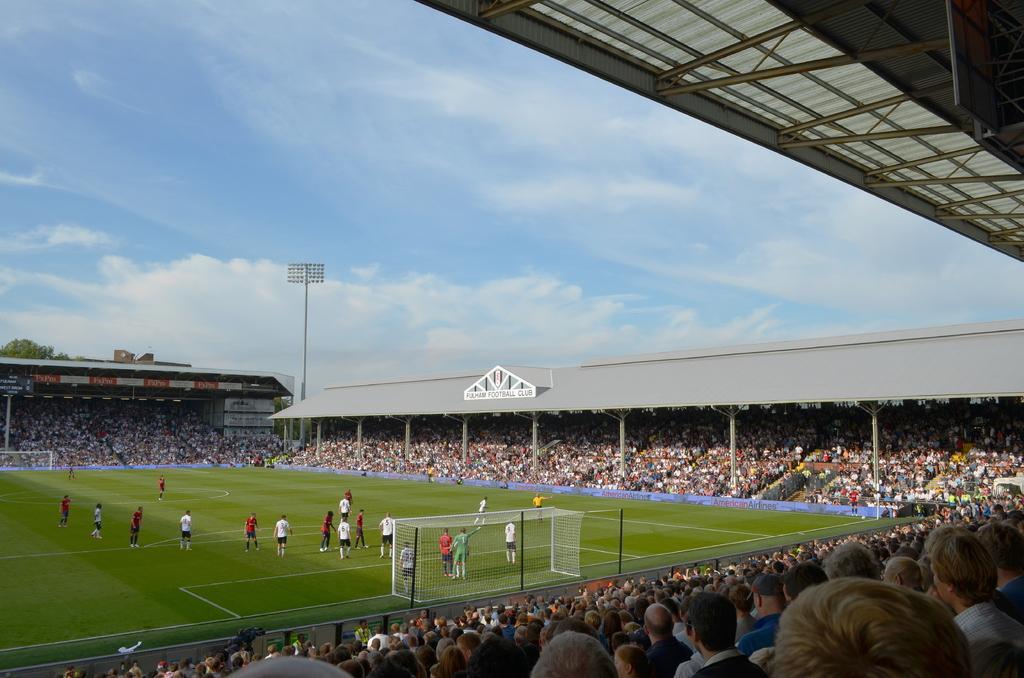Describe this image in one or two sentences. In this image we can see many people on the ground. There are two goal posts. Also there are many people sitting on stadium. And we can see a pole with a light. In the back there is tree. Also there is sky with clouds. 